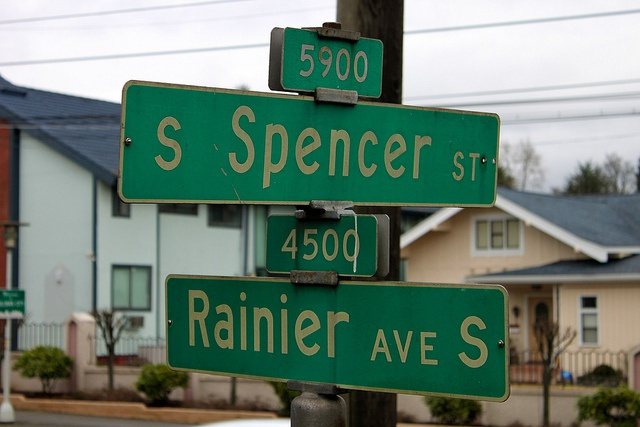Describe the objects in this image and their specific colors. I can see various objects in this image with different colors. 